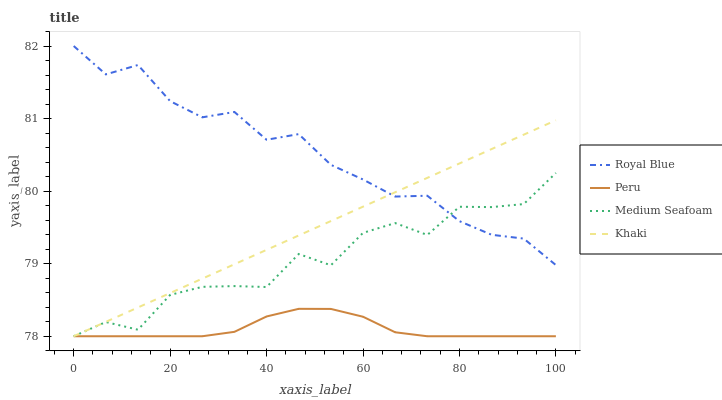Does Khaki have the minimum area under the curve?
Answer yes or no. No. Does Khaki have the maximum area under the curve?
Answer yes or no. No. Is Medium Seafoam the smoothest?
Answer yes or no. No. Is Khaki the roughest?
Answer yes or no. No. Does Khaki have the highest value?
Answer yes or no. No. Is Peru less than Royal Blue?
Answer yes or no. Yes. Is Royal Blue greater than Peru?
Answer yes or no. Yes. Does Peru intersect Royal Blue?
Answer yes or no. No. 